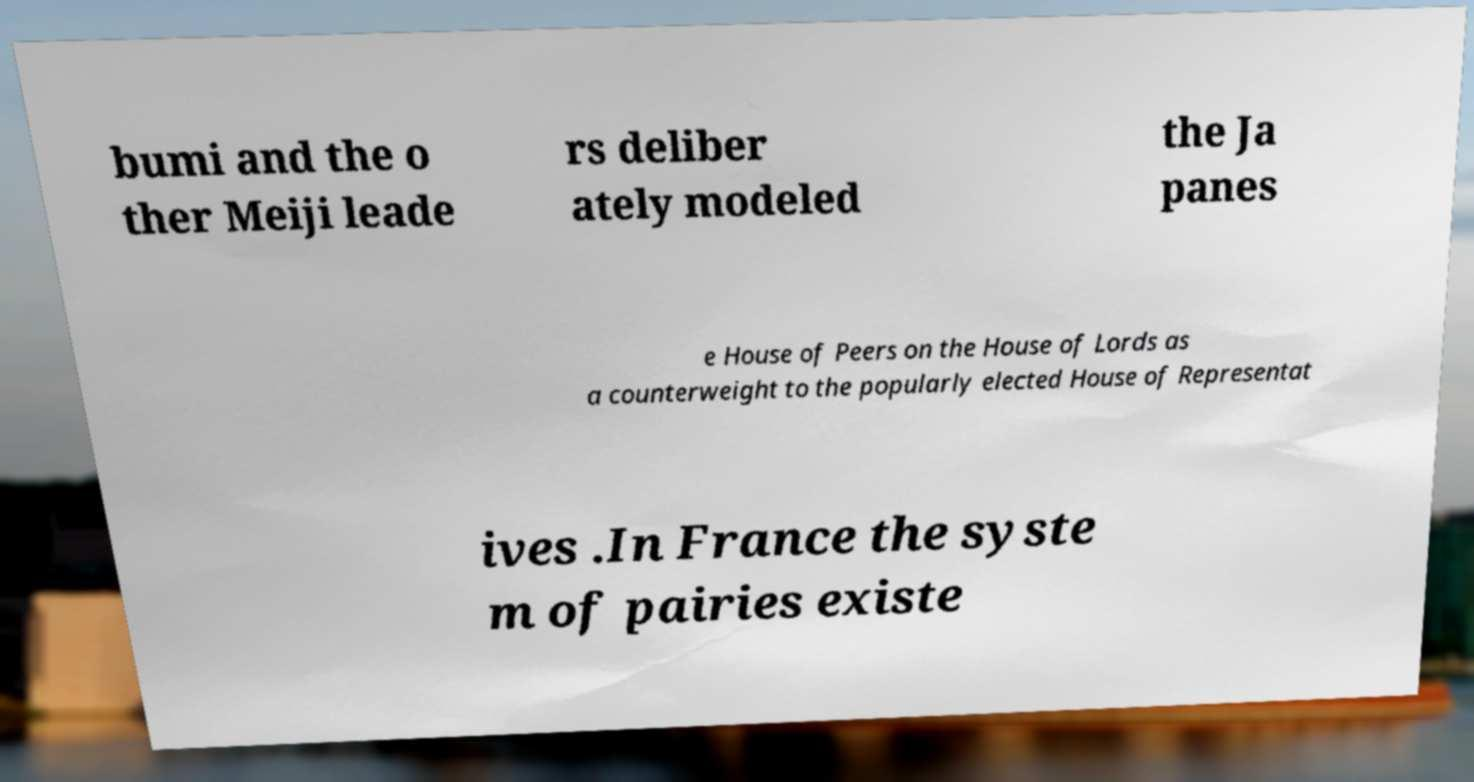Please read and relay the text visible in this image. What does it say? bumi and the o ther Meiji leade rs deliber ately modeled the Ja panes e House of Peers on the House of Lords as a counterweight to the popularly elected House of Representat ives .In France the syste m of pairies existe 